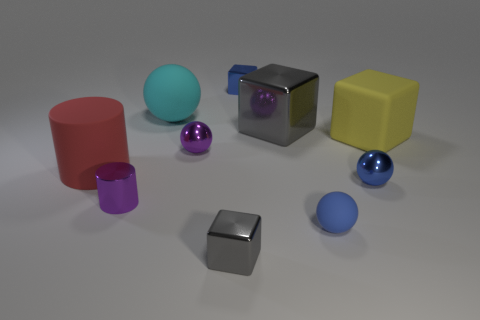Could you estimate the sizes of these objects? While it's challenging to provide exact measurements without a reference object, the yellow and grey cubes appear to be the largest items, potentially around the size of a small box you could hold in your hand. The spheres and the red cylinder are comparatively smaller, perhaps akin to the size of a tennis ball, and the purple metallic objects look to be even smaller, akin to the size of a large marble or a ping-pong ball. 